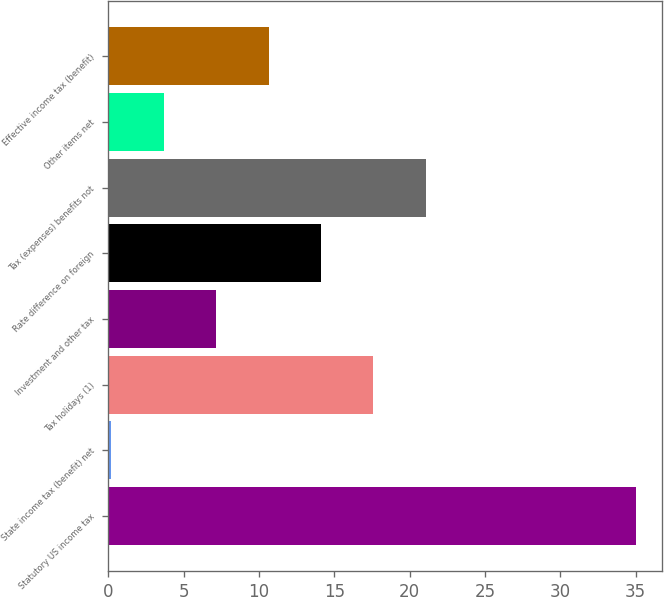Convert chart to OTSL. <chart><loc_0><loc_0><loc_500><loc_500><bar_chart><fcel>Statutory US income tax<fcel>State income tax (benefit) net<fcel>Tax holidays (1)<fcel>Investment and other tax<fcel>Rate difference on foreign<fcel>Tax (expenses) benefits not<fcel>Other items net<fcel>Effective income tax (benefit)<nl><fcel>35<fcel>0.2<fcel>17.6<fcel>7.16<fcel>14.12<fcel>21.08<fcel>3.68<fcel>10.64<nl></chart> 